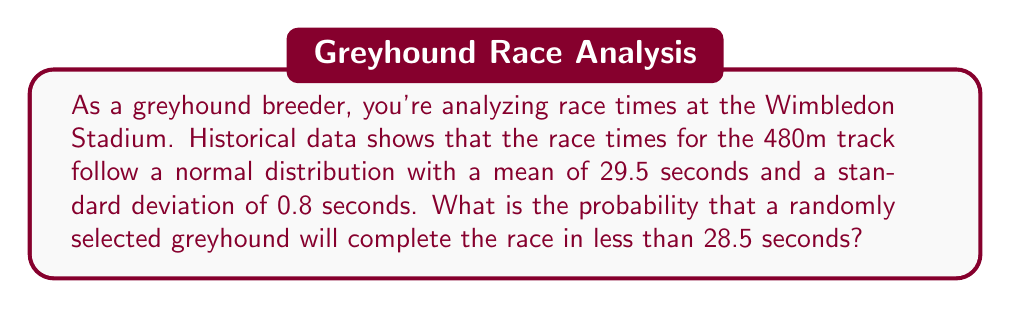Teach me how to tackle this problem. To solve this problem, we need to use the properties of the normal distribution and calculate the z-score for the given time.

Step 1: Identify the given information
- Mean (μ) = 29.5 seconds
- Standard deviation (σ) = 0.8 seconds
- Time in question (x) = 28.5 seconds

Step 2: Calculate the z-score
The z-score formula is: $z = \frac{x - μ}{σ}$

Plugging in the values:
$z = \frac{28.5 - 29.5}{0.8} = \frac{-1}{0.8} = -1.25$

Step 3: Use the standard normal distribution table or calculator
We need to find P(Z < -1.25), which is the area under the standard normal curve to the left of z = -1.25.

Using a standard normal distribution table or calculator, we find:
P(Z < -1.25) ≈ 0.1056

Step 4: Interpret the result
The probability that a randomly selected greyhound will complete the race in less than 28.5 seconds is approximately 0.1056 or 10.56%.
Answer: 0.1056 